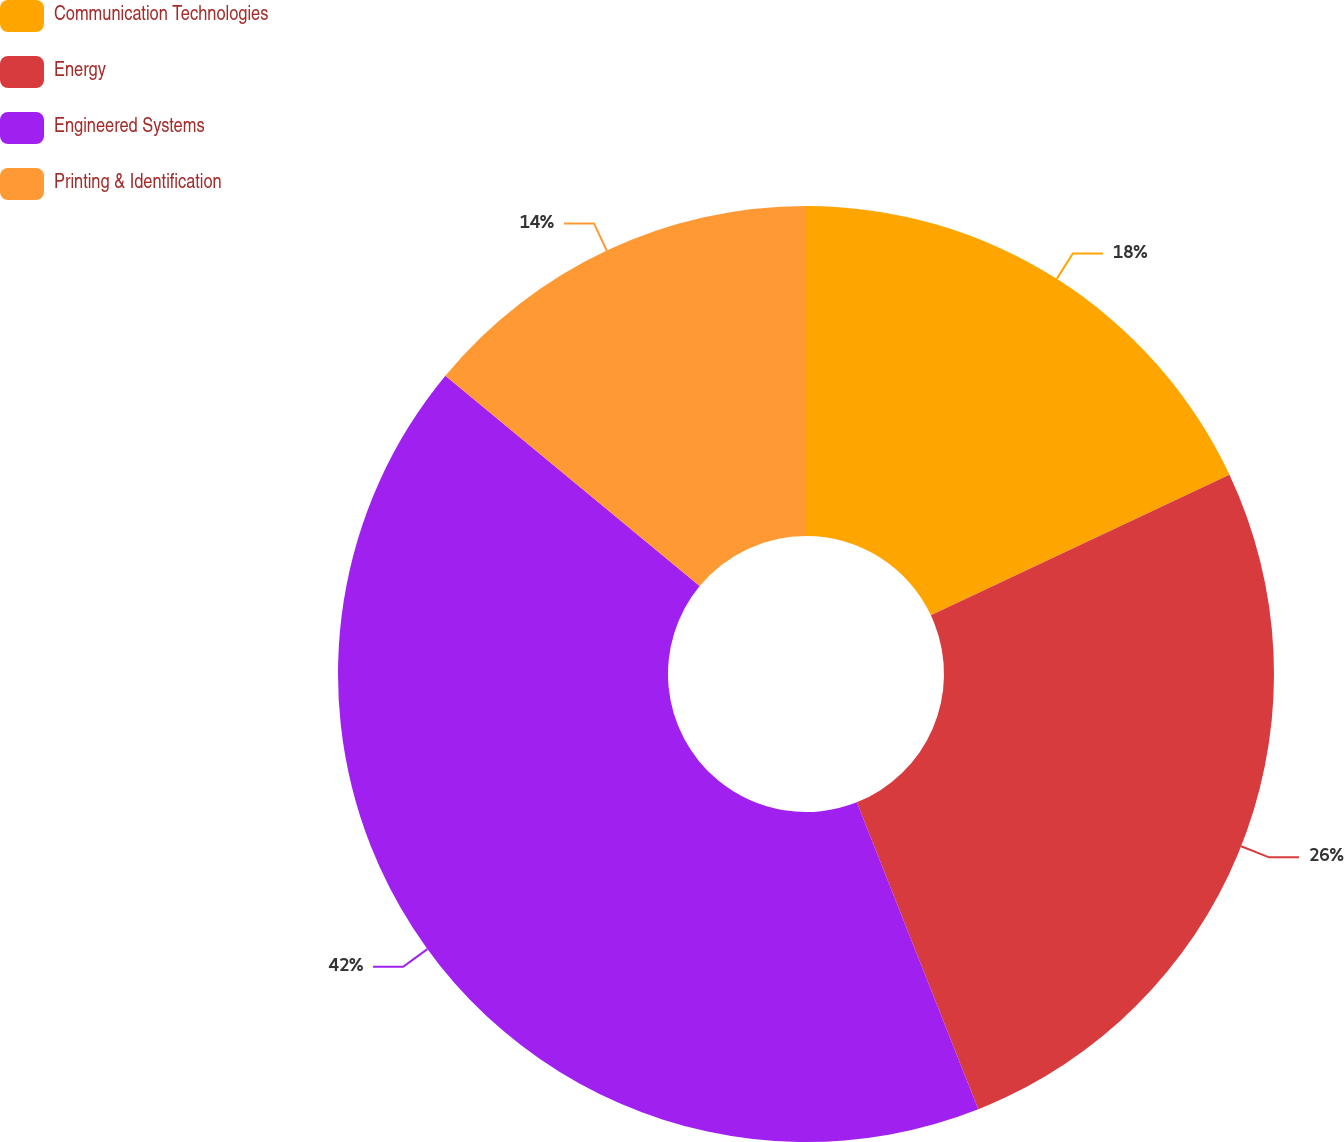<chart> <loc_0><loc_0><loc_500><loc_500><pie_chart><fcel>Communication Technologies<fcel>Energy<fcel>Engineered Systems<fcel>Printing & Identification<nl><fcel>18.0%<fcel>26.0%<fcel>42.0%<fcel>14.0%<nl></chart> 